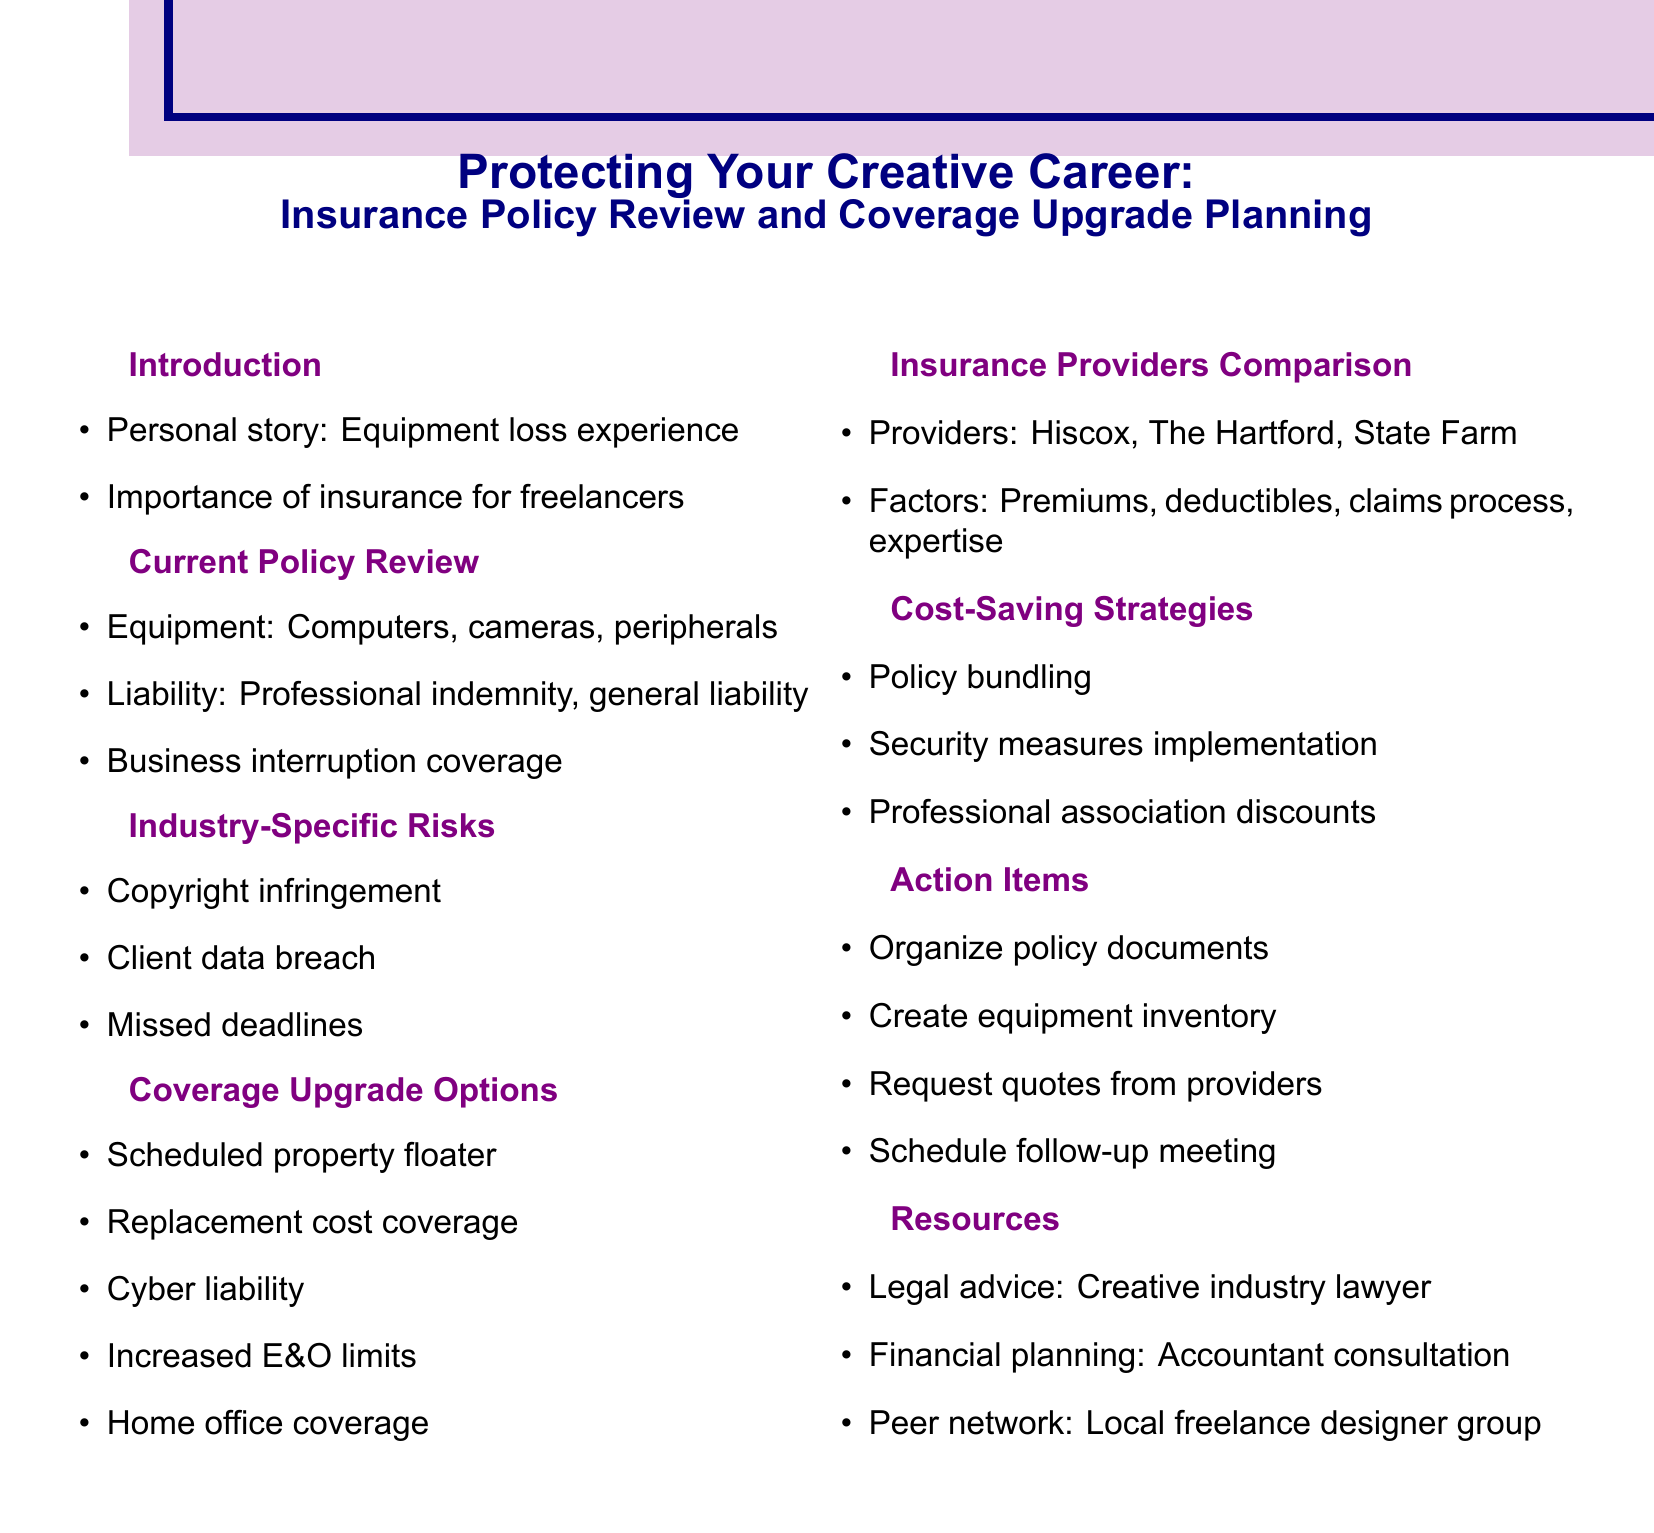What is the session title? The session title is explicitly mentioned at the beginning of the document as "Protecting Your Creative Career: Insurance Policy Review and Coverage Upgrade Planning."
Answer: Protecting Your Creative Career: Insurance Policy Review and Coverage Upgrade Planning What equipment is covered under current policy? The document lists specific equipment covered under current policy in the "Current Policy Review" section, including computers, cameras, and peripherals.
Answer: MacBook Pro, iMac, Canon EOS R5, Sony A7 III, Wacom Cintiq, external hard drives Which insurance provider is mentioned as one option? The document provides a list of insurance providers in the "Insurance Providers Comparison" section, including Hiscox.
Answer: Hiscox What is one type of coverage upgrade option available? One specific type of coverage upgrade is detailed in the "Coverage Upgrade Options" section of the document, indicating possible enhancements to insurance.
Answer: Scheduled property floater What are the three factors to consider when comparing insurance providers? The document includes a list of factors in the "Insurance Providers Comparison" section that should be considered when comparing providers.
Answer: Premium costs, Deductible options, Claim process efficiency What cost-saving strategy is suggested? In the document's "Cost-Saving Strategies" section, various strategies are mentioned, one of which focuses on combining different policies.
Answer: Bundling policies What is one action item listed in the agenda? The document outlines specific action items in the "Action Items" section, highlighting tasks to be accomplished.
Answer: Organize and digitize all current policy documents Name a legal resource recommended in the document. The document specifies resources available, particularly in the "Resources" section, with a focus on legal advice related to the creative industry.
Answer: Consult with lawyer specializing in creative industries 